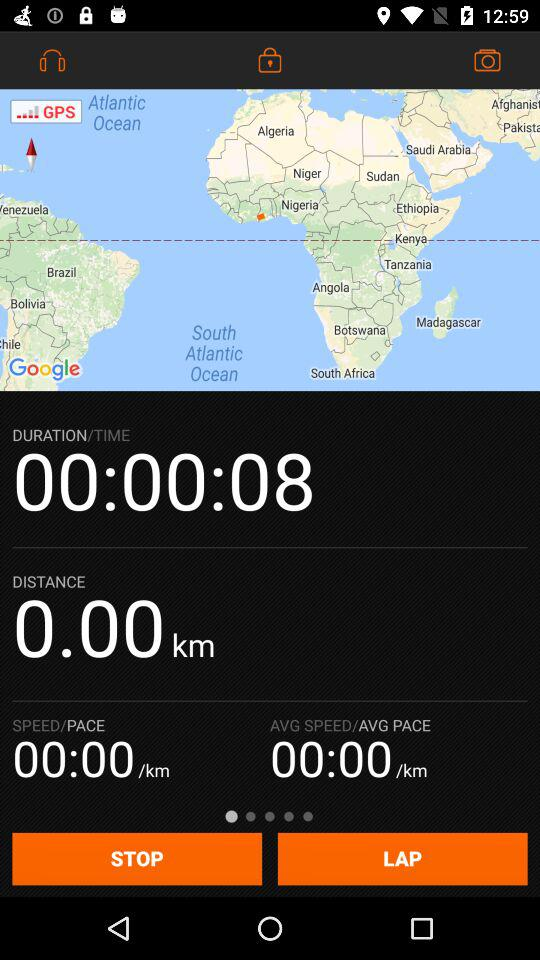How long has the current activity been going on for?
Answer the question using a single word or phrase. 00:00:08 